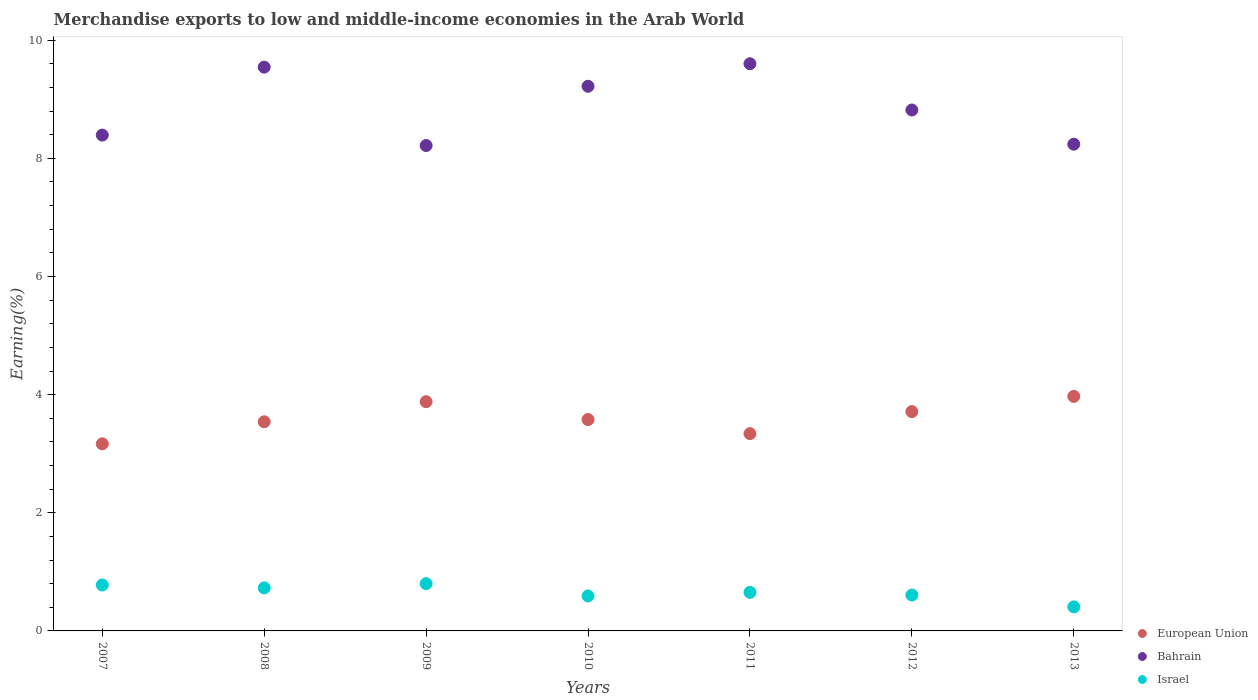Is the number of dotlines equal to the number of legend labels?
Your answer should be compact. Yes. What is the percentage of amount earned from merchandise exports in European Union in 2007?
Ensure brevity in your answer.  3.17. Across all years, what is the maximum percentage of amount earned from merchandise exports in European Union?
Offer a terse response. 3.97. Across all years, what is the minimum percentage of amount earned from merchandise exports in European Union?
Give a very brief answer. 3.17. In which year was the percentage of amount earned from merchandise exports in European Union maximum?
Ensure brevity in your answer.  2013. What is the total percentage of amount earned from merchandise exports in European Union in the graph?
Ensure brevity in your answer.  25.19. What is the difference between the percentage of amount earned from merchandise exports in European Union in 2010 and that in 2011?
Provide a succinct answer. 0.24. What is the difference between the percentage of amount earned from merchandise exports in European Union in 2011 and the percentage of amount earned from merchandise exports in Israel in 2007?
Give a very brief answer. 2.56. What is the average percentage of amount earned from merchandise exports in European Union per year?
Give a very brief answer. 3.6. In the year 2012, what is the difference between the percentage of amount earned from merchandise exports in Israel and percentage of amount earned from merchandise exports in Bahrain?
Keep it short and to the point. -8.21. What is the ratio of the percentage of amount earned from merchandise exports in European Union in 2008 to that in 2010?
Provide a short and direct response. 0.99. Is the difference between the percentage of amount earned from merchandise exports in Israel in 2008 and 2010 greater than the difference between the percentage of amount earned from merchandise exports in Bahrain in 2008 and 2010?
Keep it short and to the point. No. What is the difference between the highest and the second highest percentage of amount earned from merchandise exports in Israel?
Your answer should be very brief. 0.02. What is the difference between the highest and the lowest percentage of amount earned from merchandise exports in Israel?
Provide a short and direct response. 0.39. In how many years, is the percentage of amount earned from merchandise exports in European Union greater than the average percentage of amount earned from merchandise exports in European Union taken over all years?
Make the answer very short. 3. Is it the case that in every year, the sum of the percentage of amount earned from merchandise exports in Bahrain and percentage of amount earned from merchandise exports in European Union  is greater than the percentage of amount earned from merchandise exports in Israel?
Give a very brief answer. Yes. Is the percentage of amount earned from merchandise exports in European Union strictly less than the percentage of amount earned from merchandise exports in Bahrain over the years?
Your response must be concise. Yes. How many years are there in the graph?
Provide a succinct answer. 7. Are the values on the major ticks of Y-axis written in scientific E-notation?
Your answer should be compact. No. Does the graph contain any zero values?
Ensure brevity in your answer.  No. Where does the legend appear in the graph?
Your answer should be compact. Bottom right. How are the legend labels stacked?
Offer a very short reply. Vertical. What is the title of the graph?
Make the answer very short. Merchandise exports to low and middle-income economies in the Arab World. Does "Namibia" appear as one of the legend labels in the graph?
Offer a terse response. No. What is the label or title of the X-axis?
Keep it short and to the point. Years. What is the label or title of the Y-axis?
Offer a terse response. Earning(%). What is the Earning(%) in European Union in 2007?
Provide a short and direct response. 3.17. What is the Earning(%) of Bahrain in 2007?
Give a very brief answer. 8.39. What is the Earning(%) in Israel in 2007?
Keep it short and to the point. 0.78. What is the Earning(%) of European Union in 2008?
Your answer should be very brief. 3.54. What is the Earning(%) of Bahrain in 2008?
Offer a very short reply. 9.54. What is the Earning(%) in Israel in 2008?
Make the answer very short. 0.73. What is the Earning(%) in European Union in 2009?
Your response must be concise. 3.88. What is the Earning(%) of Bahrain in 2009?
Keep it short and to the point. 8.22. What is the Earning(%) of Israel in 2009?
Make the answer very short. 0.8. What is the Earning(%) in European Union in 2010?
Your answer should be compact. 3.58. What is the Earning(%) of Bahrain in 2010?
Your answer should be compact. 9.22. What is the Earning(%) in Israel in 2010?
Your answer should be compact. 0.59. What is the Earning(%) of European Union in 2011?
Provide a short and direct response. 3.34. What is the Earning(%) in Bahrain in 2011?
Ensure brevity in your answer.  9.6. What is the Earning(%) of Israel in 2011?
Offer a terse response. 0.65. What is the Earning(%) in European Union in 2012?
Keep it short and to the point. 3.71. What is the Earning(%) in Bahrain in 2012?
Give a very brief answer. 8.82. What is the Earning(%) in Israel in 2012?
Your answer should be very brief. 0.61. What is the Earning(%) of European Union in 2013?
Your answer should be very brief. 3.97. What is the Earning(%) in Bahrain in 2013?
Keep it short and to the point. 8.24. What is the Earning(%) of Israel in 2013?
Give a very brief answer. 0.41. Across all years, what is the maximum Earning(%) in European Union?
Provide a short and direct response. 3.97. Across all years, what is the maximum Earning(%) in Bahrain?
Offer a terse response. 9.6. Across all years, what is the maximum Earning(%) of Israel?
Your answer should be compact. 0.8. Across all years, what is the minimum Earning(%) in European Union?
Offer a very short reply. 3.17. Across all years, what is the minimum Earning(%) of Bahrain?
Ensure brevity in your answer.  8.22. Across all years, what is the minimum Earning(%) in Israel?
Your response must be concise. 0.41. What is the total Earning(%) in European Union in the graph?
Make the answer very short. 25.19. What is the total Earning(%) in Bahrain in the graph?
Offer a very short reply. 62.04. What is the total Earning(%) of Israel in the graph?
Provide a short and direct response. 4.56. What is the difference between the Earning(%) of European Union in 2007 and that in 2008?
Offer a very short reply. -0.37. What is the difference between the Earning(%) in Bahrain in 2007 and that in 2008?
Your answer should be very brief. -1.15. What is the difference between the Earning(%) of Israel in 2007 and that in 2008?
Your answer should be compact. 0.05. What is the difference between the Earning(%) of European Union in 2007 and that in 2009?
Ensure brevity in your answer.  -0.71. What is the difference between the Earning(%) in Bahrain in 2007 and that in 2009?
Keep it short and to the point. 0.18. What is the difference between the Earning(%) of Israel in 2007 and that in 2009?
Make the answer very short. -0.02. What is the difference between the Earning(%) in European Union in 2007 and that in 2010?
Your response must be concise. -0.41. What is the difference between the Earning(%) in Bahrain in 2007 and that in 2010?
Your response must be concise. -0.83. What is the difference between the Earning(%) of Israel in 2007 and that in 2010?
Provide a short and direct response. 0.19. What is the difference between the Earning(%) of European Union in 2007 and that in 2011?
Give a very brief answer. -0.17. What is the difference between the Earning(%) in Bahrain in 2007 and that in 2011?
Offer a very short reply. -1.21. What is the difference between the Earning(%) in Israel in 2007 and that in 2011?
Give a very brief answer. 0.12. What is the difference between the Earning(%) in European Union in 2007 and that in 2012?
Give a very brief answer. -0.55. What is the difference between the Earning(%) of Bahrain in 2007 and that in 2012?
Give a very brief answer. -0.42. What is the difference between the Earning(%) in Israel in 2007 and that in 2012?
Your answer should be compact. 0.17. What is the difference between the Earning(%) of European Union in 2007 and that in 2013?
Offer a very short reply. -0.8. What is the difference between the Earning(%) in Bahrain in 2007 and that in 2013?
Give a very brief answer. 0.15. What is the difference between the Earning(%) of Israel in 2007 and that in 2013?
Keep it short and to the point. 0.37. What is the difference between the Earning(%) in European Union in 2008 and that in 2009?
Ensure brevity in your answer.  -0.34. What is the difference between the Earning(%) in Bahrain in 2008 and that in 2009?
Offer a terse response. 1.33. What is the difference between the Earning(%) in Israel in 2008 and that in 2009?
Make the answer very short. -0.07. What is the difference between the Earning(%) of European Union in 2008 and that in 2010?
Provide a succinct answer. -0.04. What is the difference between the Earning(%) of Bahrain in 2008 and that in 2010?
Make the answer very short. 0.32. What is the difference between the Earning(%) of Israel in 2008 and that in 2010?
Offer a terse response. 0.14. What is the difference between the Earning(%) in European Union in 2008 and that in 2011?
Provide a succinct answer. 0.2. What is the difference between the Earning(%) in Bahrain in 2008 and that in 2011?
Make the answer very short. -0.06. What is the difference between the Earning(%) in Israel in 2008 and that in 2011?
Provide a succinct answer. 0.08. What is the difference between the Earning(%) of European Union in 2008 and that in 2012?
Your answer should be very brief. -0.17. What is the difference between the Earning(%) in Bahrain in 2008 and that in 2012?
Your answer should be compact. 0.73. What is the difference between the Earning(%) in Israel in 2008 and that in 2012?
Offer a terse response. 0.12. What is the difference between the Earning(%) in European Union in 2008 and that in 2013?
Offer a very short reply. -0.43. What is the difference between the Earning(%) of Bahrain in 2008 and that in 2013?
Your answer should be very brief. 1.3. What is the difference between the Earning(%) in Israel in 2008 and that in 2013?
Ensure brevity in your answer.  0.32. What is the difference between the Earning(%) in European Union in 2009 and that in 2010?
Your answer should be very brief. 0.3. What is the difference between the Earning(%) in Bahrain in 2009 and that in 2010?
Your answer should be very brief. -1. What is the difference between the Earning(%) in Israel in 2009 and that in 2010?
Give a very brief answer. 0.21. What is the difference between the Earning(%) in European Union in 2009 and that in 2011?
Keep it short and to the point. 0.54. What is the difference between the Earning(%) of Bahrain in 2009 and that in 2011?
Your response must be concise. -1.38. What is the difference between the Earning(%) in Israel in 2009 and that in 2011?
Provide a succinct answer. 0.15. What is the difference between the Earning(%) in European Union in 2009 and that in 2012?
Provide a short and direct response. 0.17. What is the difference between the Earning(%) in Bahrain in 2009 and that in 2012?
Your answer should be very brief. -0.6. What is the difference between the Earning(%) in Israel in 2009 and that in 2012?
Make the answer very short. 0.19. What is the difference between the Earning(%) of European Union in 2009 and that in 2013?
Provide a short and direct response. -0.09. What is the difference between the Earning(%) in Bahrain in 2009 and that in 2013?
Offer a very short reply. -0.02. What is the difference between the Earning(%) in Israel in 2009 and that in 2013?
Provide a short and direct response. 0.39. What is the difference between the Earning(%) in European Union in 2010 and that in 2011?
Offer a very short reply. 0.24. What is the difference between the Earning(%) in Bahrain in 2010 and that in 2011?
Your answer should be very brief. -0.38. What is the difference between the Earning(%) of Israel in 2010 and that in 2011?
Ensure brevity in your answer.  -0.06. What is the difference between the Earning(%) of European Union in 2010 and that in 2012?
Your answer should be very brief. -0.14. What is the difference between the Earning(%) of Bahrain in 2010 and that in 2012?
Provide a short and direct response. 0.4. What is the difference between the Earning(%) in Israel in 2010 and that in 2012?
Offer a very short reply. -0.02. What is the difference between the Earning(%) in European Union in 2010 and that in 2013?
Your answer should be very brief. -0.39. What is the difference between the Earning(%) in Bahrain in 2010 and that in 2013?
Make the answer very short. 0.98. What is the difference between the Earning(%) of Israel in 2010 and that in 2013?
Give a very brief answer. 0.18. What is the difference between the Earning(%) in European Union in 2011 and that in 2012?
Provide a short and direct response. -0.37. What is the difference between the Earning(%) of Bahrain in 2011 and that in 2012?
Offer a terse response. 0.78. What is the difference between the Earning(%) of Israel in 2011 and that in 2012?
Your response must be concise. 0.05. What is the difference between the Earning(%) in European Union in 2011 and that in 2013?
Give a very brief answer. -0.63. What is the difference between the Earning(%) of Bahrain in 2011 and that in 2013?
Your answer should be very brief. 1.36. What is the difference between the Earning(%) of Israel in 2011 and that in 2013?
Your answer should be compact. 0.25. What is the difference between the Earning(%) in European Union in 2012 and that in 2013?
Your response must be concise. -0.26. What is the difference between the Earning(%) of Bahrain in 2012 and that in 2013?
Provide a succinct answer. 0.58. What is the difference between the Earning(%) in Israel in 2012 and that in 2013?
Offer a very short reply. 0.2. What is the difference between the Earning(%) of European Union in 2007 and the Earning(%) of Bahrain in 2008?
Keep it short and to the point. -6.38. What is the difference between the Earning(%) in European Union in 2007 and the Earning(%) in Israel in 2008?
Your response must be concise. 2.44. What is the difference between the Earning(%) of Bahrain in 2007 and the Earning(%) of Israel in 2008?
Your response must be concise. 7.67. What is the difference between the Earning(%) of European Union in 2007 and the Earning(%) of Bahrain in 2009?
Your response must be concise. -5.05. What is the difference between the Earning(%) of European Union in 2007 and the Earning(%) of Israel in 2009?
Provide a succinct answer. 2.37. What is the difference between the Earning(%) in Bahrain in 2007 and the Earning(%) in Israel in 2009?
Provide a short and direct response. 7.59. What is the difference between the Earning(%) of European Union in 2007 and the Earning(%) of Bahrain in 2010?
Your response must be concise. -6.05. What is the difference between the Earning(%) of European Union in 2007 and the Earning(%) of Israel in 2010?
Offer a very short reply. 2.58. What is the difference between the Earning(%) of Bahrain in 2007 and the Earning(%) of Israel in 2010?
Ensure brevity in your answer.  7.8. What is the difference between the Earning(%) in European Union in 2007 and the Earning(%) in Bahrain in 2011?
Ensure brevity in your answer.  -6.43. What is the difference between the Earning(%) of European Union in 2007 and the Earning(%) of Israel in 2011?
Provide a succinct answer. 2.51. What is the difference between the Earning(%) in Bahrain in 2007 and the Earning(%) in Israel in 2011?
Offer a terse response. 7.74. What is the difference between the Earning(%) of European Union in 2007 and the Earning(%) of Bahrain in 2012?
Your response must be concise. -5.65. What is the difference between the Earning(%) in European Union in 2007 and the Earning(%) in Israel in 2012?
Provide a succinct answer. 2.56. What is the difference between the Earning(%) in Bahrain in 2007 and the Earning(%) in Israel in 2012?
Your answer should be compact. 7.79. What is the difference between the Earning(%) of European Union in 2007 and the Earning(%) of Bahrain in 2013?
Offer a very short reply. -5.07. What is the difference between the Earning(%) of European Union in 2007 and the Earning(%) of Israel in 2013?
Offer a terse response. 2.76. What is the difference between the Earning(%) in Bahrain in 2007 and the Earning(%) in Israel in 2013?
Keep it short and to the point. 7.99. What is the difference between the Earning(%) of European Union in 2008 and the Earning(%) of Bahrain in 2009?
Provide a succinct answer. -4.68. What is the difference between the Earning(%) in European Union in 2008 and the Earning(%) in Israel in 2009?
Ensure brevity in your answer.  2.74. What is the difference between the Earning(%) of Bahrain in 2008 and the Earning(%) of Israel in 2009?
Offer a terse response. 8.74. What is the difference between the Earning(%) of European Union in 2008 and the Earning(%) of Bahrain in 2010?
Offer a terse response. -5.68. What is the difference between the Earning(%) of European Union in 2008 and the Earning(%) of Israel in 2010?
Your answer should be compact. 2.95. What is the difference between the Earning(%) of Bahrain in 2008 and the Earning(%) of Israel in 2010?
Offer a very short reply. 8.95. What is the difference between the Earning(%) in European Union in 2008 and the Earning(%) in Bahrain in 2011?
Provide a succinct answer. -6.06. What is the difference between the Earning(%) in European Union in 2008 and the Earning(%) in Israel in 2011?
Your answer should be very brief. 2.89. What is the difference between the Earning(%) in Bahrain in 2008 and the Earning(%) in Israel in 2011?
Make the answer very short. 8.89. What is the difference between the Earning(%) in European Union in 2008 and the Earning(%) in Bahrain in 2012?
Make the answer very short. -5.28. What is the difference between the Earning(%) of European Union in 2008 and the Earning(%) of Israel in 2012?
Your response must be concise. 2.93. What is the difference between the Earning(%) in Bahrain in 2008 and the Earning(%) in Israel in 2012?
Your answer should be very brief. 8.94. What is the difference between the Earning(%) in European Union in 2008 and the Earning(%) in Bahrain in 2013?
Your answer should be compact. -4.7. What is the difference between the Earning(%) in European Union in 2008 and the Earning(%) in Israel in 2013?
Keep it short and to the point. 3.13. What is the difference between the Earning(%) of Bahrain in 2008 and the Earning(%) of Israel in 2013?
Your answer should be compact. 9.14. What is the difference between the Earning(%) of European Union in 2009 and the Earning(%) of Bahrain in 2010?
Your answer should be compact. -5.34. What is the difference between the Earning(%) in European Union in 2009 and the Earning(%) in Israel in 2010?
Give a very brief answer. 3.29. What is the difference between the Earning(%) of Bahrain in 2009 and the Earning(%) of Israel in 2010?
Your answer should be compact. 7.63. What is the difference between the Earning(%) of European Union in 2009 and the Earning(%) of Bahrain in 2011?
Keep it short and to the point. -5.72. What is the difference between the Earning(%) in European Union in 2009 and the Earning(%) in Israel in 2011?
Provide a short and direct response. 3.23. What is the difference between the Earning(%) in Bahrain in 2009 and the Earning(%) in Israel in 2011?
Ensure brevity in your answer.  7.56. What is the difference between the Earning(%) in European Union in 2009 and the Earning(%) in Bahrain in 2012?
Provide a short and direct response. -4.94. What is the difference between the Earning(%) in European Union in 2009 and the Earning(%) in Israel in 2012?
Offer a very short reply. 3.27. What is the difference between the Earning(%) of Bahrain in 2009 and the Earning(%) of Israel in 2012?
Your response must be concise. 7.61. What is the difference between the Earning(%) in European Union in 2009 and the Earning(%) in Bahrain in 2013?
Provide a succinct answer. -4.36. What is the difference between the Earning(%) of European Union in 2009 and the Earning(%) of Israel in 2013?
Offer a terse response. 3.47. What is the difference between the Earning(%) of Bahrain in 2009 and the Earning(%) of Israel in 2013?
Offer a very short reply. 7.81. What is the difference between the Earning(%) in European Union in 2010 and the Earning(%) in Bahrain in 2011?
Your answer should be very brief. -6.02. What is the difference between the Earning(%) of European Union in 2010 and the Earning(%) of Israel in 2011?
Your answer should be compact. 2.93. What is the difference between the Earning(%) of Bahrain in 2010 and the Earning(%) of Israel in 2011?
Your answer should be compact. 8.57. What is the difference between the Earning(%) in European Union in 2010 and the Earning(%) in Bahrain in 2012?
Keep it short and to the point. -5.24. What is the difference between the Earning(%) in European Union in 2010 and the Earning(%) in Israel in 2012?
Offer a terse response. 2.97. What is the difference between the Earning(%) in Bahrain in 2010 and the Earning(%) in Israel in 2012?
Your answer should be compact. 8.61. What is the difference between the Earning(%) in European Union in 2010 and the Earning(%) in Bahrain in 2013?
Provide a succinct answer. -4.66. What is the difference between the Earning(%) in European Union in 2010 and the Earning(%) in Israel in 2013?
Your answer should be very brief. 3.17. What is the difference between the Earning(%) in Bahrain in 2010 and the Earning(%) in Israel in 2013?
Provide a short and direct response. 8.81. What is the difference between the Earning(%) of European Union in 2011 and the Earning(%) of Bahrain in 2012?
Your response must be concise. -5.48. What is the difference between the Earning(%) of European Union in 2011 and the Earning(%) of Israel in 2012?
Keep it short and to the point. 2.73. What is the difference between the Earning(%) of Bahrain in 2011 and the Earning(%) of Israel in 2012?
Your response must be concise. 8.99. What is the difference between the Earning(%) in European Union in 2011 and the Earning(%) in Bahrain in 2013?
Your answer should be compact. -4.9. What is the difference between the Earning(%) of European Union in 2011 and the Earning(%) of Israel in 2013?
Your answer should be compact. 2.93. What is the difference between the Earning(%) in Bahrain in 2011 and the Earning(%) in Israel in 2013?
Make the answer very short. 9.19. What is the difference between the Earning(%) of European Union in 2012 and the Earning(%) of Bahrain in 2013?
Your answer should be very brief. -4.53. What is the difference between the Earning(%) in European Union in 2012 and the Earning(%) in Israel in 2013?
Make the answer very short. 3.31. What is the difference between the Earning(%) in Bahrain in 2012 and the Earning(%) in Israel in 2013?
Your response must be concise. 8.41. What is the average Earning(%) of European Union per year?
Give a very brief answer. 3.6. What is the average Earning(%) of Bahrain per year?
Keep it short and to the point. 8.86. What is the average Earning(%) in Israel per year?
Ensure brevity in your answer.  0.65. In the year 2007, what is the difference between the Earning(%) of European Union and Earning(%) of Bahrain?
Ensure brevity in your answer.  -5.23. In the year 2007, what is the difference between the Earning(%) of European Union and Earning(%) of Israel?
Offer a very short reply. 2.39. In the year 2007, what is the difference between the Earning(%) in Bahrain and Earning(%) in Israel?
Provide a succinct answer. 7.62. In the year 2008, what is the difference between the Earning(%) in European Union and Earning(%) in Bahrain?
Ensure brevity in your answer.  -6. In the year 2008, what is the difference between the Earning(%) of European Union and Earning(%) of Israel?
Provide a short and direct response. 2.81. In the year 2008, what is the difference between the Earning(%) of Bahrain and Earning(%) of Israel?
Your answer should be very brief. 8.82. In the year 2009, what is the difference between the Earning(%) in European Union and Earning(%) in Bahrain?
Keep it short and to the point. -4.34. In the year 2009, what is the difference between the Earning(%) of European Union and Earning(%) of Israel?
Give a very brief answer. 3.08. In the year 2009, what is the difference between the Earning(%) in Bahrain and Earning(%) in Israel?
Keep it short and to the point. 7.42. In the year 2010, what is the difference between the Earning(%) in European Union and Earning(%) in Bahrain?
Keep it short and to the point. -5.64. In the year 2010, what is the difference between the Earning(%) of European Union and Earning(%) of Israel?
Your answer should be very brief. 2.99. In the year 2010, what is the difference between the Earning(%) of Bahrain and Earning(%) of Israel?
Your answer should be compact. 8.63. In the year 2011, what is the difference between the Earning(%) of European Union and Earning(%) of Bahrain?
Your response must be concise. -6.26. In the year 2011, what is the difference between the Earning(%) in European Union and Earning(%) in Israel?
Ensure brevity in your answer.  2.69. In the year 2011, what is the difference between the Earning(%) of Bahrain and Earning(%) of Israel?
Give a very brief answer. 8.95. In the year 2012, what is the difference between the Earning(%) in European Union and Earning(%) in Bahrain?
Your response must be concise. -5.11. In the year 2012, what is the difference between the Earning(%) in European Union and Earning(%) in Israel?
Your response must be concise. 3.11. In the year 2012, what is the difference between the Earning(%) of Bahrain and Earning(%) of Israel?
Your answer should be very brief. 8.21. In the year 2013, what is the difference between the Earning(%) in European Union and Earning(%) in Bahrain?
Offer a terse response. -4.27. In the year 2013, what is the difference between the Earning(%) of European Union and Earning(%) of Israel?
Keep it short and to the point. 3.56. In the year 2013, what is the difference between the Earning(%) of Bahrain and Earning(%) of Israel?
Your answer should be compact. 7.83. What is the ratio of the Earning(%) in European Union in 2007 to that in 2008?
Keep it short and to the point. 0.89. What is the ratio of the Earning(%) of Bahrain in 2007 to that in 2008?
Your response must be concise. 0.88. What is the ratio of the Earning(%) in Israel in 2007 to that in 2008?
Make the answer very short. 1.07. What is the ratio of the Earning(%) in European Union in 2007 to that in 2009?
Keep it short and to the point. 0.82. What is the ratio of the Earning(%) of Bahrain in 2007 to that in 2009?
Ensure brevity in your answer.  1.02. What is the ratio of the Earning(%) of Israel in 2007 to that in 2009?
Your answer should be compact. 0.97. What is the ratio of the Earning(%) in European Union in 2007 to that in 2010?
Keep it short and to the point. 0.89. What is the ratio of the Earning(%) of Bahrain in 2007 to that in 2010?
Ensure brevity in your answer.  0.91. What is the ratio of the Earning(%) of Israel in 2007 to that in 2010?
Ensure brevity in your answer.  1.31. What is the ratio of the Earning(%) in European Union in 2007 to that in 2011?
Give a very brief answer. 0.95. What is the ratio of the Earning(%) of Bahrain in 2007 to that in 2011?
Provide a succinct answer. 0.87. What is the ratio of the Earning(%) of Israel in 2007 to that in 2011?
Your answer should be very brief. 1.19. What is the ratio of the Earning(%) of European Union in 2007 to that in 2012?
Keep it short and to the point. 0.85. What is the ratio of the Earning(%) of Bahrain in 2007 to that in 2012?
Give a very brief answer. 0.95. What is the ratio of the Earning(%) of Israel in 2007 to that in 2012?
Provide a succinct answer. 1.28. What is the ratio of the Earning(%) in European Union in 2007 to that in 2013?
Provide a succinct answer. 0.8. What is the ratio of the Earning(%) in Bahrain in 2007 to that in 2013?
Ensure brevity in your answer.  1.02. What is the ratio of the Earning(%) of Israel in 2007 to that in 2013?
Your answer should be very brief. 1.91. What is the ratio of the Earning(%) in European Union in 2008 to that in 2009?
Your response must be concise. 0.91. What is the ratio of the Earning(%) of Bahrain in 2008 to that in 2009?
Ensure brevity in your answer.  1.16. What is the ratio of the Earning(%) in Israel in 2008 to that in 2009?
Make the answer very short. 0.91. What is the ratio of the Earning(%) in Bahrain in 2008 to that in 2010?
Provide a short and direct response. 1.04. What is the ratio of the Earning(%) in Israel in 2008 to that in 2010?
Make the answer very short. 1.23. What is the ratio of the Earning(%) of European Union in 2008 to that in 2011?
Provide a short and direct response. 1.06. What is the ratio of the Earning(%) in Bahrain in 2008 to that in 2011?
Your answer should be very brief. 0.99. What is the ratio of the Earning(%) in Israel in 2008 to that in 2011?
Provide a short and direct response. 1.12. What is the ratio of the Earning(%) of European Union in 2008 to that in 2012?
Offer a terse response. 0.95. What is the ratio of the Earning(%) in Bahrain in 2008 to that in 2012?
Provide a short and direct response. 1.08. What is the ratio of the Earning(%) in Israel in 2008 to that in 2012?
Your answer should be compact. 1.2. What is the ratio of the Earning(%) of European Union in 2008 to that in 2013?
Ensure brevity in your answer.  0.89. What is the ratio of the Earning(%) in Bahrain in 2008 to that in 2013?
Keep it short and to the point. 1.16. What is the ratio of the Earning(%) of Israel in 2008 to that in 2013?
Keep it short and to the point. 1.79. What is the ratio of the Earning(%) in European Union in 2009 to that in 2010?
Your response must be concise. 1.08. What is the ratio of the Earning(%) of Bahrain in 2009 to that in 2010?
Offer a very short reply. 0.89. What is the ratio of the Earning(%) in Israel in 2009 to that in 2010?
Provide a succinct answer. 1.35. What is the ratio of the Earning(%) of European Union in 2009 to that in 2011?
Keep it short and to the point. 1.16. What is the ratio of the Earning(%) in Bahrain in 2009 to that in 2011?
Offer a terse response. 0.86. What is the ratio of the Earning(%) of Israel in 2009 to that in 2011?
Provide a succinct answer. 1.23. What is the ratio of the Earning(%) in European Union in 2009 to that in 2012?
Keep it short and to the point. 1.05. What is the ratio of the Earning(%) in Bahrain in 2009 to that in 2012?
Offer a very short reply. 0.93. What is the ratio of the Earning(%) in Israel in 2009 to that in 2012?
Make the answer very short. 1.32. What is the ratio of the Earning(%) of European Union in 2009 to that in 2013?
Give a very brief answer. 0.98. What is the ratio of the Earning(%) of Israel in 2009 to that in 2013?
Keep it short and to the point. 1.97. What is the ratio of the Earning(%) in European Union in 2010 to that in 2011?
Provide a succinct answer. 1.07. What is the ratio of the Earning(%) in Bahrain in 2010 to that in 2011?
Your answer should be compact. 0.96. What is the ratio of the Earning(%) of Israel in 2010 to that in 2011?
Give a very brief answer. 0.91. What is the ratio of the Earning(%) in European Union in 2010 to that in 2012?
Provide a succinct answer. 0.96. What is the ratio of the Earning(%) in Bahrain in 2010 to that in 2012?
Provide a short and direct response. 1.05. What is the ratio of the Earning(%) in Israel in 2010 to that in 2012?
Provide a short and direct response. 0.97. What is the ratio of the Earning(%) in European Union in 2010 to that in 2013?
Offer a very short reply. 0.9. What is the ratio of the Earning(%) in Bahrain in 2010 to that in 2013?
Your answer should be compact. 1.12. What is the ratio of the Earning(%) of Israel in 2010 to that in 2013?
Give a very brief answer. 1.45. What is the ratio of the Earning(%) of European Union in 2011 to that in 2012?
Provide a succinct answer. 0.9. What is the ratio of the Earning(%) in Bahrain in 2011 to that in 2012?
Make the answer very short. 1.09. What is the ratio of the Earning(%) in Israel in 2011 to that in 2012?
Your response must be concise. 1.07. What is the ratio of the Earning(%) in European Union in 2011 to that in 2013?
Provide a short and direct response. 0.84. What is the ratio of the Earning(%) of Bahrain in 2011 to that in 2013?
Make the answer very short. 1.17. What is the ratio of the Earning(%) of Israel in 2011 to that in 2013?
Provide a succinct answer. 1.6. What is the ratio of the Earning(%) of European Union in 2012 to that in 2013?
Your answer should be compact. 0.94. What is the ratio of the Earning(%) in Bahrain in 2012 to that in 2013?
Provide a succinct answer. 1.07. What is the ratio of the Earning(%) in Israel in 2012 to that in 2013?
Ensure brevity in your answer.  1.49. What is the difference between the highest and the second highest Earning(%) of European Union?
Your answer should be very brief. 0.09. What is the difference between the highest and the second highest Earning(%) in Bahrain?
Offer a very short reply. 0.06. What is the difference between the highest and the second highest Earning(%) of Israel?
Give a very brief answer. 0.02. What is the difference between the highest and the lowest Earning(%) of European Union?
Ensure brevity in your answer.  0.8. What is the difference between the highest and the lowest Earning(%) of Bahrain?
Your answer should be compact. 1.38. What is the difference between the highest and the lowest Earning(%) in Israel?
Your answer should be very brief. 0.39. 